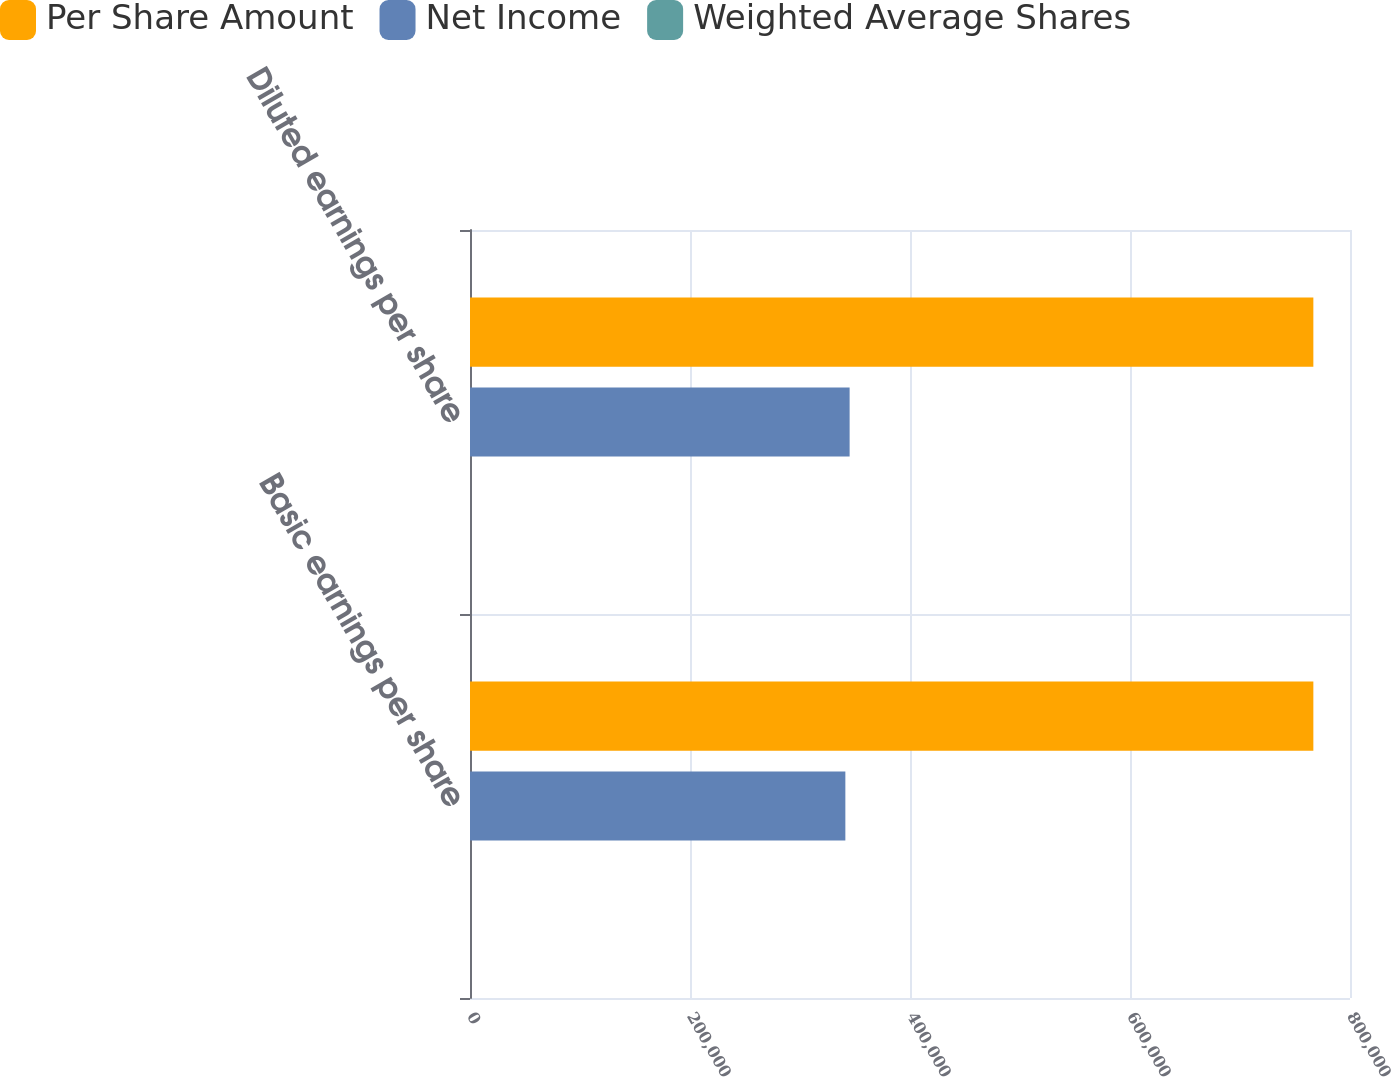Convert chart to OTSL. <chart><loc_0><loc_0><loc_500><loc_500><stacked_bar_chart><ecel><fcel>Basic earnings per share<fcel>Diluted earnings per share<nl><fcel>Per Share Amount<fcel>766685<fcel>766685<nl><fcel>Net Income<fcel>341234<fcel>345117<nl><fcel>Weighted Average Shares<fcel>2.25<fcel>2.22<nl></chart> 